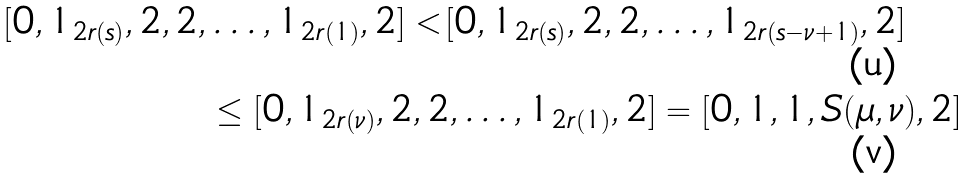<formula> <loc_0><loc_0><loc_500><loc_500>[ 0 , 1 _ { 2 r ( s ) } , 2 , 2 , & \dots , 1 _ { 2 r ( 1 ) } , 2 ] < [ 0 , 1 _ { 2 r ( s ) } , 2 , 2 , \dots , 1 _ { 2 r ( s - \nu + 1 ) } , 2 ] \\ & \leq [ 0 , 1 _ { 2 r ( \nu ) } , 2 , 2 , \dots , 1 _ { 2 r ( 1 ) } , 2 ] = [ 0 , 1 , 1 , S ( \mu , \nu ) , 2 ]</formula> 